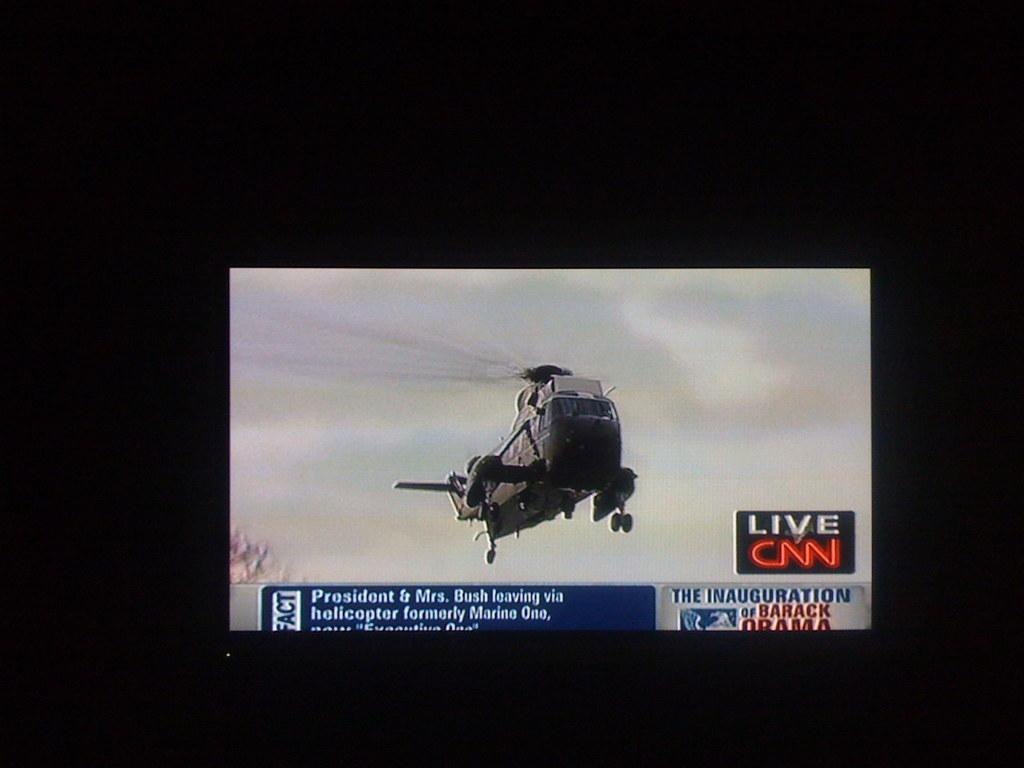How would you summarize this image in a sentence or two? In this picture there is a television which has a plane flying in the air and there is something written below it is displayed on it. 